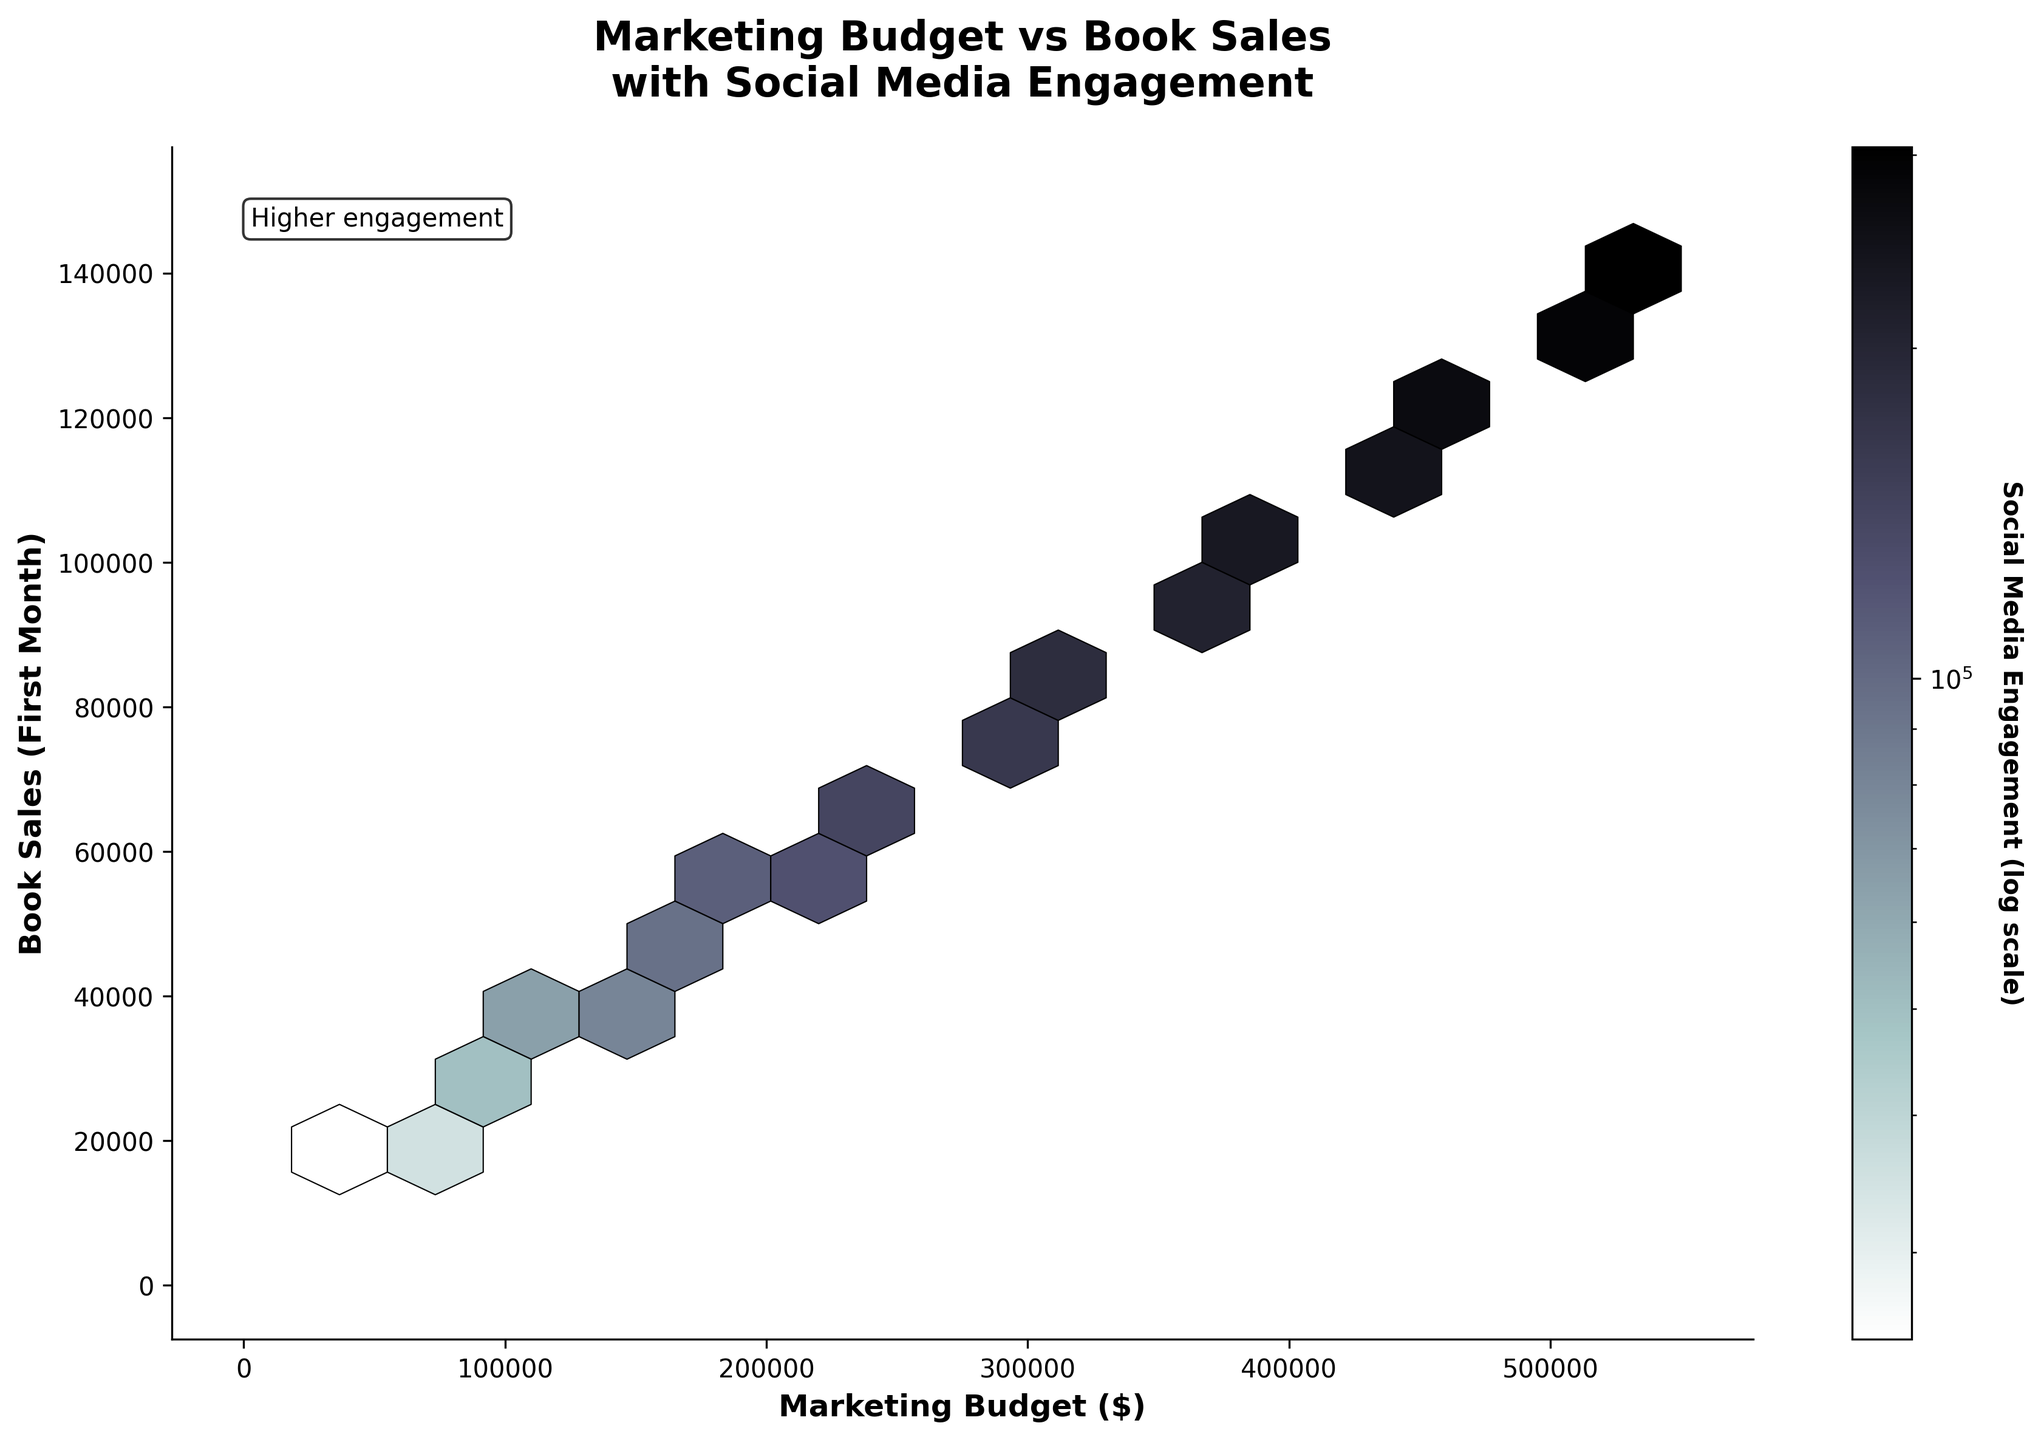What is the title of the plot? The title of the plot is located at the top of the figure and it reads "Marketing Budget vs Book Sales\nwith Social Media Engagement".
Answer: Marketing Budget vs Book Sales\nwith Social Media Engagement What are the axes labels in the figure? The x-axis is labeled "Marketing Budget ($)" and the y-axis is labeled "Book Sales (First Month)".
Answer: Marketing Budget ($) and Book Sales (First Month) What color gradient is used for representing social media engagement? The figure uses a gradient from lighter to darker shades to represent different levels of social media engagement, with darker colors indicating higher engagement.
Answer: Lighter to darker shades How is social media engagement quantified in the color bar? The color bar represents social media engagement in a logarithmic scale. This means the differences in shades demonstrate exponential changes in engagement.
Answer: Logarithmic scale What does a darker hexbin indicate in terms of data points? Darker hexbins indicate higher social media engagement within the range of marketing budget and book sales represented by that region of the plot.
Answer: Higher social media engagement What is the general trend between marketing budget and book sales? As the marketing budget increases, there's a notable increase in book sales, indicating a positive correlation.
Answer: Positive correlation At what approximate marketing budget do book sales start exceeding 100,000 in the first month? According to the plot, book sales start exceeding 100,000 units/month when the marketing budget is around 400,000 dollars.
Answer: Around 400,000 dollars In which range of marketing budget and book sales, is social media engagement the highest? Social media engagement is highest in the upper range of the plot, typically where the marketing budget is above 375,000 dollars and book sales exceed 100,000 units/month.
Answer: Above 375,000 dollars marketing budget and above 100,000 units/month book sales How does social media engagement change as book sales increase, given a fixed marketing budget? At a fixed marketing budget, social media engagement tends to increase as book sales increase, shown by darker hexbins at higher book sales within the same marketing budget range.
Answer: Increases Is there any noticeable difference in social media engagement for lower marketing budgets compared to higher ones? Yes, for lower marketing budgets, social media engagement tends to be lower as indicated by lighter hexbins, whereas for higher marketing budgets, engagement is higher, shown by darker hexbins.
Answer: Yes, lower for lower budgets, and higher for higher budgets 